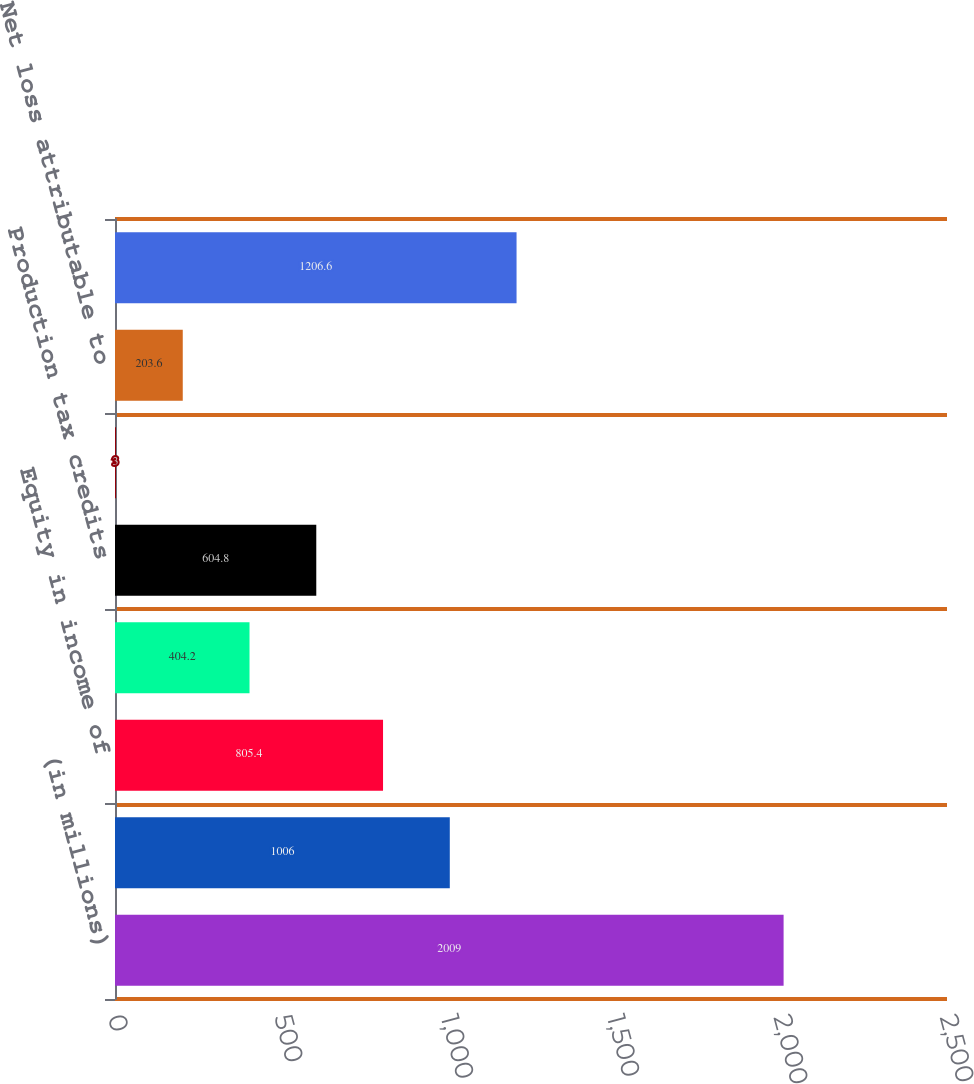Convert chart. <chart><loc_0><loc_0><loc_500><loc_500><bar_chart><fcel>(in millions)<fcel>AOI<fcel>Equity in income of<fcel>Dividend income from projects<fcel>Production tax credits<fcel>Other income net<fcel>Net loss attributable to<fcel>Operating Income (Loss)<nl><fcel>2009<fcel>1006<fcel>805.4<fcel>404.2<fcel>604.8<fcel>3<fcel>203.6<fcel>1206.6<nl></chart> 